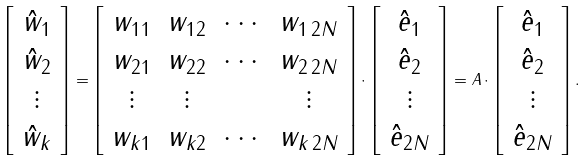Convert formula to latex. <formula><loc_0><loc_0><loc_500><loc_500>\left [ \begin{array} { c } \hat { w } _ { 1 } \\ \hat { w } _ { 2 } \\ \vdots \\ \hat { w } _ { k } \end{array} \right ] = \left [ \begin{array} { c c c c } w _ { 1 1 } & w _ { 1 2 } & \cdots & w _ { 1 \, 2 N } \\ w _ { 2 1 } & w _ { 2 2 } & \cdots & w _ { 2 \, 2 N } \\ \vdots & \vdots & & \vdots \\ w _ { k 1 } & w _ { k 2 } & \cdots & w _ { k \, 2 N } \end{array} \right ] \cdot \left [ \begin{array} { c } \hat { e } _ { 1 } \\ \hat { e } _ { 2 } \\ \vdots \\ \hat { e } _ { 2 N } \end{array} \right ] = A \cdot \left [ \begin{array} { c } \hat { e } _ { 1 } \\ \hat { e } _ { 2 } \\ \vdots \\ \hat { e } _ { 2 N } \end{array} \right ] . \,</formula> 